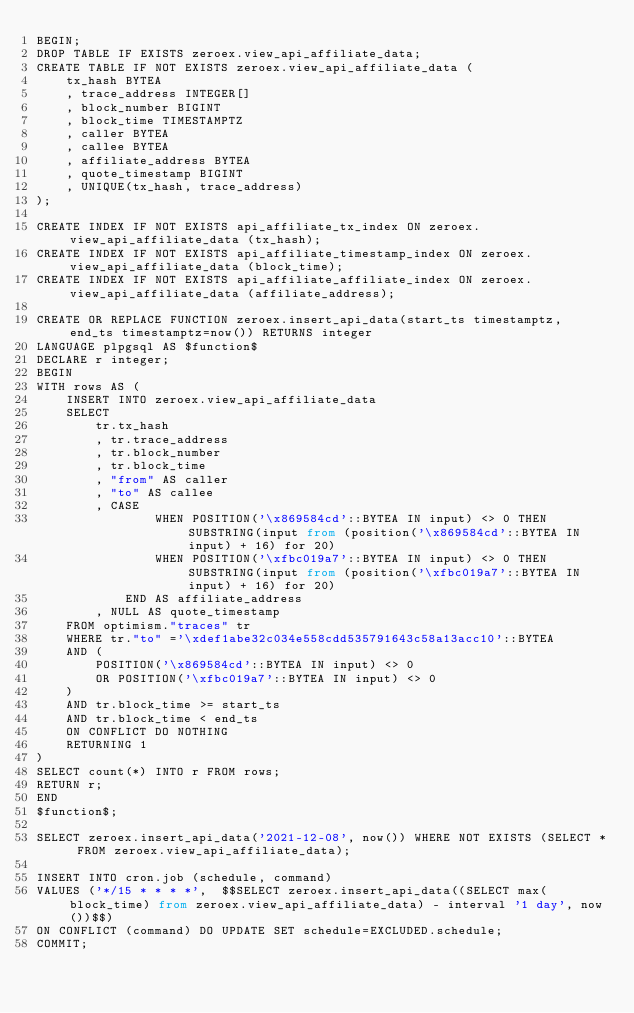Convert code to text. <code><loc_0><loc_0><loc_500><loc_500><_SQL_>BEGIN;
DROP TABLE IF EXISTS zeroex.view_api_affiliate_data;
CREATE TABLE IF NOT EXISTS zeroex.view_api_affiliate_data (
    tx_hash BYTEA
    , trace_address INTEGER[]
    , block_number BIGINT
    , block_time TIMESTAMPTZ
    , caller BYTEA
    , callee BYTEA
    , affiliate_address BYTEA
    , quote_timestamp BIGINT
    , UNIQUE(tx_hash, trace_address)
);

CREATE INDEX IF NOT EXISTS api_affiliate_tx_index ON zeroex.view_api_affiliate_data (tx_hash);
CREATE INDEX IF NOT EXISTS api_affiliate_timestamp_index ON zeroex.view_api_affiliate_data (block_time);
CREATE INDEX IF NOT EXISTS api_affiliate_affiliate_index ON zeroex.view_api_affiliate_data (affiliate_address);

CREATE OR REPLACE FUNCTION zeroex.insert_api_data(start_ts timestamptz, end_ts timestamptz=now()) RETURNS integer
LANGUAGE plpgsql AS $function$
DECLARE r integer;
BEGIN
WITH rows AS (
    INSERT INTO zeroex.view_api_affiliate_data
    SELECT
        tr.tx_hash
        , tr.trace_address
        , tr.block_number
        , tr.block_time
        , "from" AS caller
        , "to" AS callee
        , CASE
                WHEN POSITION('\x869584cd'::BYTEA IN input) <> 0 THEN SUBSTRING(input from (position('\x869584cd'::BYTEA IN input) + 16) for 20)
                WHEN POSITION('\xfbc019a7'::BYTEA IN input) <> 0 THEN SUBSTRING(input from (position('\xfbc019a7'::BYTEA IN input) + 16) for 20)
            END AS affiliate_address
        , NULL AS quote_timestamp
    FROM optimism."traces" tr
    WHERE tr."to" ='\xdef1abe32c034e558cdd535791643c58a13acc10'::BYTEA
    AND (
        POSITION('\x869584cd'::BYTEA IN input) <> 0
        OR POSITION('\xfbc019a7'::BYTEA IN input) <> 0
    )
    AND tr.block_time >= start_ts
    AND tr.block_time < end_ts
    ON CONFLICT DO NOTHING
    RETURNING 1
)
SELECT count(*) INTO r FROM rows;
RETURN r;
END
$function$;

SELECT zeroex.insert_api_data('2021-12-08', now()) WHERE NOT EXISTS (SELECT * FROM zeroex.view_api_affiliate_data);

INSERT INTO cron.job (schedule, command)
VALUES ('*/15 * * * *',  $$SELECT zeroex.insert_api_data((SELECT max(block_time) from zeroex.view_api_affiliate_data) - interval '1 day', now())$$)
ON CONFLICT (command) DO UPDATE SET schedule=EXCLUDED.schedule;
COMMIT;
</code> 